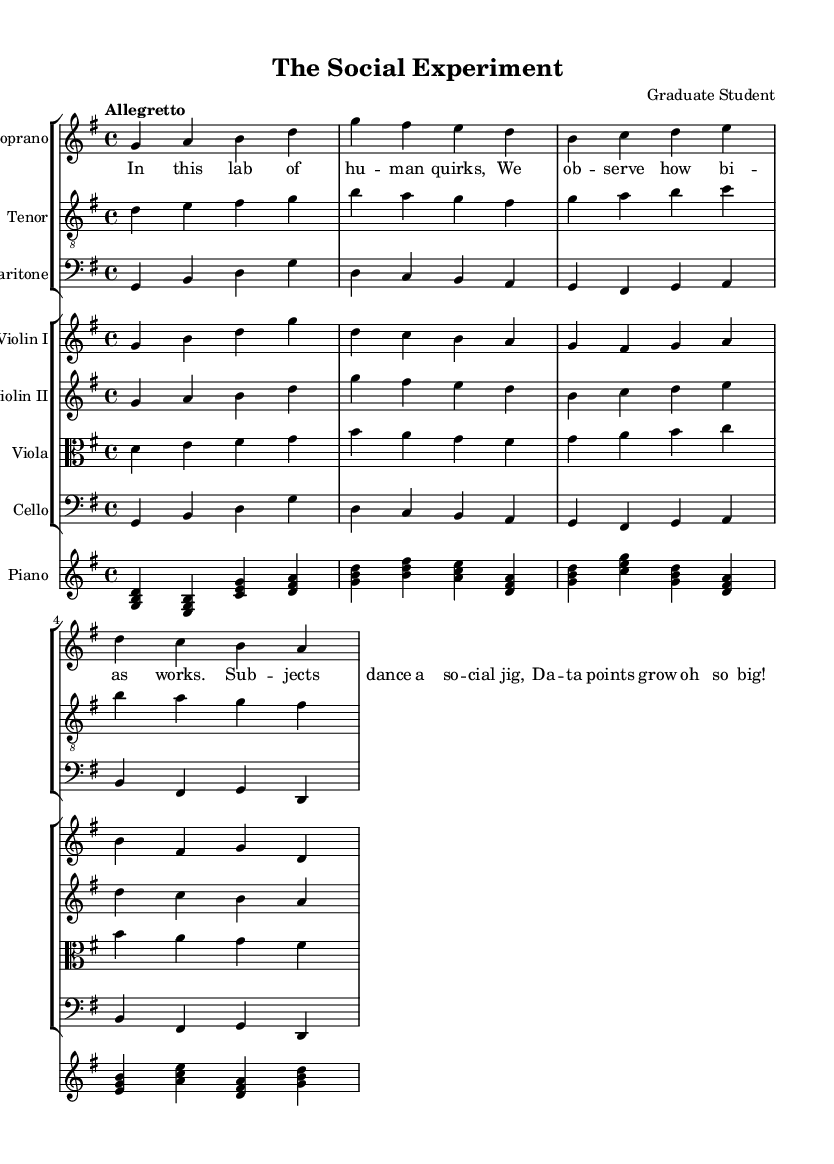What is the key signature of this music? The key signature indicated at the beginning of the piece shows one sharp, which corresponds to G major.
Answer: G major What is the time signature of this music? The time signature is displayed as a fraction at the beginning of the sheet music indicating four beats in each measure, with a quarter note getting one beat.
Answer: 4/4 What is the tempo marking for this piece? The tempo marking at the start of the score describes the speed of the piece as "Allegretto," which is generally a moderate tempo.
Answer: Allegretto Which instruments are used in this opera? The score includes multiple instrument parts listed in the staff groups: soprano, tenor, baritone, violin I, violin II, viola, cello, and piano.
Answer: Soprano, tenor, baritone, violin I, violin II, viola, cello, piano What is the overall theme depicted in the lyrics? The lyrics reflect an observation of social interactions and bias within a laboratory setting, emphasizing human quirks and dynamics.
Answer: Social interactions and bias How many vocal parts are there in this composition? The score indicates three distinct vocal parts: soprano, tenor, and baritone, each represented in separate staves.
Answer: Three What is the significance of the group dynamics portrayed in this opera? The text and music together suggest that the scenes highlight group dynamics and individual behaviors within social experiments, illustrating the interactions among subjects.
Answer: Group dynamics and individual behaviors 